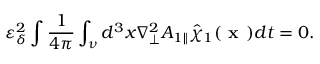Convert formula to latex. <formula><loc_0><loc_0><loc_500><loc_500>\varepsilon _ { \delta } ^ { 2 } \int o p \frac { 1 } { 4 \pi } \int _ { \nu } d ^ { 3 } x \nabla _ { \perp } ^ { 2 } { A } _ { 1 \| } \hat { \chi } _ { 1 } ( x ) d t = 0 .</formula> 